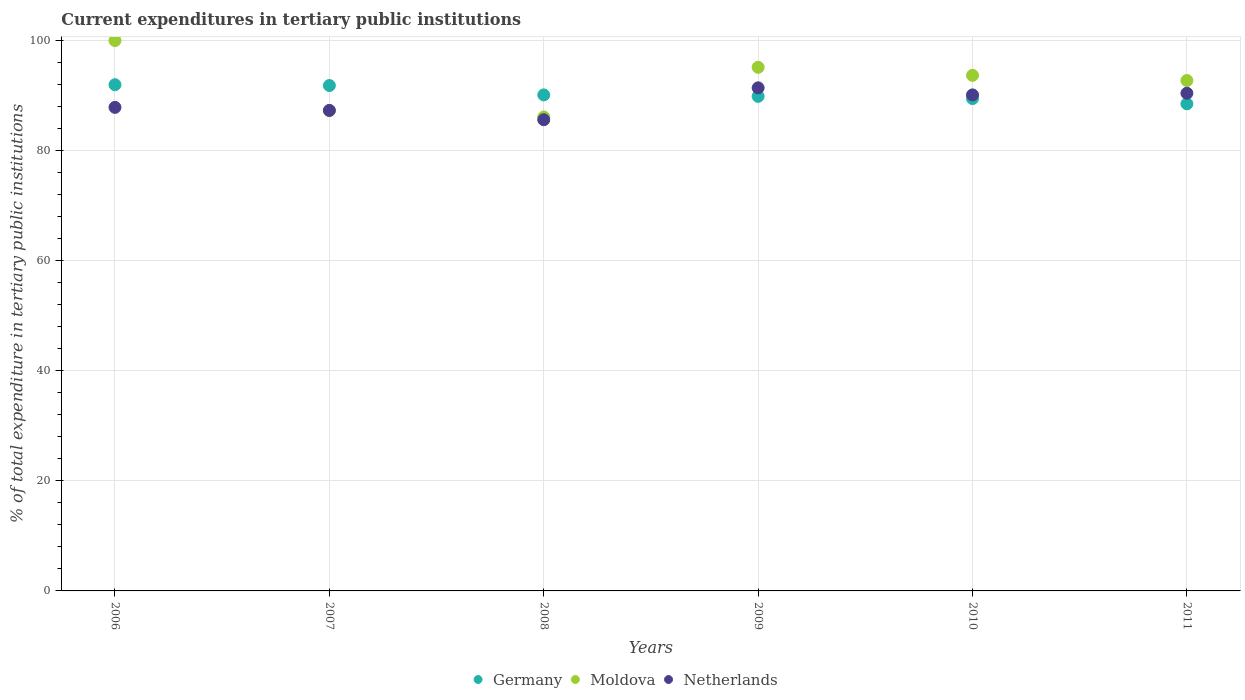How many different coloured dotlines are there?
Provide a short and direct response. 3. What is the current expenditures in tertiary public institutions in Netherlands in 2009?
Offer a terse response. 91.41. Across all years, what is the maximum current expenditures in tertiary public institutions in Netherlands?
Make the answer very short. 91.41. Across all years, what is the minimum current expenditures in tertiary public institutions in Netherlands?
Keep it short and to the point. 85.61. In which year was the current expenditures in tertiary public institutions in Netherlands maximum?
Keep it short and to the point. 2009. What is the total current expenditures in tertiary public institutions in Moldova in the graph?
Offer a very short reply. 554.92. What is the difference between the current expenditures in tertiary public institutions in Netherlands in 2007 and that in 2009?
Offer a very short reply. -4.1. What is the difference between the current expenditures in tertiary public institutions in Moldova in 2011 and the current expenditures in tertiary public institutions in Netherlands in 2009?
Your answer should be compact. 1.33. What is the average current expenditures in tertiary public institutions in Netherlands per year?
Provide a short and direct response. 88.79. In the year 2008, what is the difference between the current expenditures in tertiary public institutions in Moldova and current expenditures in tertiary public institutions in Germany?
Your answer should be very brief. -4.01. In how many years, is the current expenditures in tertiary public institutions in Moldova greater than 96 %?
Your response must be concise. 1. What is the ratio of the current expenditures in tertiary public institutions in Moldova in 2006 to that in 2007?
Offer a very short reply. 1.15. Is the current expenditures in tertiary public institutions in Netherlands in 2006 less than that in 2011?
Your response must be concise. Yes. What is the difference between the highest and the second highest current expenditures in tertiary public institutions in Germany?
Ensure brevity in your answer.  0.15. What is the difference between the highest and the lowest current expenditures in tertiary public institutions in Germany?
Offer a very short reply. 3.47. Does the current expenditures in tertiary public institutions in Germany monotonically increase over the years?
Offer a terse response. No. Is the current expenditures in tertiary public institutions in Moldova strictly greater than the current expenditures in tertiary public institutions in Germany over the years?
Make the answer very short. No. How many dotlines are there?
Give a very brief answer. 3. What is the difference between two consecutive major ticks on the Y-axis?
Offer a terse response. 20. Does the graph contain grids?
Keep it short and to the point. Yes. Where does the legend appear in the graph?
Provide a short and direct response. Bottom center. How many legend labels are there?
Your answer should be compact. 3. How are the legend labels stacked?
Ensure brevity in your answer.  Horizontal. What is the title of the graph?
Your answer should be compact. Current expenditures in tertiary public institutions. What is the label or title of the X-axis?
Offer a terse response. Years. What is the label or title of the Y-axis?
Give a very brief answer. % of total expenditure in tertiary public institutions. What is the % of total expenditure in tertiary public institutions in Germany in 2006?
Provide a succinct answer. 91.97. What is the % of total expenditure in tertiary public institutions in Moldova in 2006?
Make the answer very short. 100. What is the % of total expenditure in tertiary public institutions in Netherlands in 2006?
Your answer should be compact. 87.86. What is the % of total expenditure in tertiary public institutions of Germany in 2007?
Give a very brief answer. 91.83. What is the % of total expenditure in tertiary public institutions in Moldova in 2007?
Give a very brief answer. 87.26. What is the % of total expenditure in tertiary public institutions of Netherlands in 2007?
Give a very brief answer. 87.31. What is the % of total expenditure in tertiary public institutions of Germany in 2008?
Make the answer very short. 90.12. What is the % of total expenditure in tertiary public institutions of Moldova in 2008?
Keep it short and to the point. 86.11. What is the % of total expenditure in tertiary public institutions of Netherlands in 2008?
Provide a short and direct response. 85.61. What is the % of total expenditure in tertiary public institutions of Germany in 2009?
Offer a very short reply. 89.86. What is the % of total expenditure in tertiary public institutions of Moldova in 2009?
Your answer should be compact. 95.13. What is the % of total expenditure in tertiary public institutions in Netherlands in 2009?
Offer a very short reply. 91.41. What is the % of total expenditure in tertiary public institutions of Germany in 2010?
Your answer should be compact. 89.45. What is the % of total expenditure in tertiary public institutions of Moldova in 2010?
Offer a very short reply. 93.68. What is the % of total expenditure in tertiary public institutions of Netherlands in 2010?
Make the answer very short. 90.12. What is the % of total expenditure in tertiary public institutions of Germany in 2011?
Offer a very short reply. 88.5. What is the % of total expenditure in tertiary public institutions in Moldova in 2011?
Your answer should be very brief. 92.74. What is the % of total expenditure in tertiary public institutions in Netherlands in 2011?
Your answer should be very brief. 90.42. Across all years, what is the maximum % of total expenditure in tertiary public institutions in Germany?
Provide a succinct answer. 91.97. Across all years, what is the maximum % of total expenditure in tertiary public institutions of Moldova?
Keep it short and to the point. 100. Across all years, what is the maximum % of total expenditure in tertiary public institutions of Netherlands?
Offer a terse response. 91.41. Across all years, what is the minimum % of total expenditure in tertiary public institutions of Germany?
Provide a short and direct response. 88.5. Across all years, what is the minimum % of total expenditure in tertiary public institutions in Moldova?
Provide a short and direct response. 86.11. Across all years, what is the minimum % of total expenditure in tertiary public institutions in Netherlands?
Your answer should be compact. 85.61. What is the total % of total expenditure in tertiary public institutions in Germany in the graph?
Your answer should be very brief. 541.74. What is the total % of total expenditure in tertiary public institutions in Moldova in the graph?
Your answer should be compact. 554.92. What is the total % of total expenditure in tertiary public institutions in Netherlands in the graph?
Ensure brevity in your answer.  532.73. What is the difference between the % of total expenditure in tertiary public institutions in Germany in 2006 and that in 2007?
Offer a very short reply. 0.15. What is the difference between the % of total expenditure in tertiary public institutions of Moldova in 2006 and that in 2007?
Provide a short and direct response. 12.74. What is the difference between the % of total expenditure in tertiary public institutions of Netherlands in 2006 and that in 2007?
Your response must be concise. 0.55. What is the difference between the % of total expenditure in tertiary public institutions of Germany in 2006 and that in 2008?
Provide a succinct answer. 1.85. What is the difference between the % of total expenditure in tertiary public institutions in Moldova in 2006 and that in 2008?
Provide a succinct answer. 13.89. What is the difference between the % of total expenditure in tertiary public institutions in Netherlands in 2006 and that in 2008?
Give a very brief answer. 2.24. What is the difference between the % of total expenditure in tertiary public institutions of Germany in 2006 and that in 2009?
Ensure brevity in your answer.  2.11. What is the difference between the % of total expenditure in tertiary public institutions in Moldova in 2006 and that in 2009?
Give a very brief answer. 4.87. What is the difference between the % of total expenditure in tertiary public institutions in Netherlands in 2006 and that in 2009?
Keep it short and to the point. -3.55. What is the difference between the % of total expenditure in tertiary public institutions of Germany in 2006 and that in 2010?
Make the answer very short. 2.52. What is the difference between the % of total expenditure in tertiary public institutions of Moldova in 2006 and that in 2010?
Offer a terse response. 6.32. What is the difference between the % of total expenditure in tertiary public institutions of Netherlands in 2006 and that in 2010?
Ensure brevity in your answer.  -2.26. What is the difference between the % of total expenditure in tertiary public institutions of Germany in 2006 and that in 2011?
Keep it short and to the point. 3.47. What is the difference between the % of total expenditure in tertiary public institutions of Moldova in 2006 and that in 2011?
Ensure brevity in your answer.  7.26. What is the difference between the % of total expenditure in tertiary public institutions of Netherlands in 2006 and that in 2011?
Keep it short and to the point. -2.57. What is the difference between the % of total expenditure in tertiary public institutions in Germany in 2007 and that in 2008?
Offer a terse response. 1.7. What is the difference between the % of total expenditure in tertiary public institutions in Moldova in 2007 and that in 2008?
Offer a very short reply. 1.15. What is the difference between the % of total expenditure in tertiary public institutions of Netherlands in 2007 and that in 2008?
Offer a very short reply. 1.69. What is the difference between the % of total expenditure in tertiary public institutions in Germany in 2007 and that in 2009?
Give a very brief answer. 1.97. What is the difference between the % of total expenditure in tertiary public institutions of Moldova in 2007 and that in 2009?
Provide a short and direct response. -7.87. What is the difference between the % of total expenditure in tertiary public institutions in Netherlands in 2007 and that in 2009?
Give a very brief answer. -4.1. What is the difference between the % of total expenditure in tertiary public institutions of Germany in 2007 and that in 2010?
Keep it short and to the point. 2.37. What is the difference between the % of total expenditure in tertiary public institutions of Moldova in 2007 and that in 2010?
Offer a very short reply. -6.41. What is the difference between the % of total expenditure in tertiary public institutions of Netherlands in 2007 and that in 2010?
Your response must be concise. -2.81. What is the difference between the % of total expenditure in tertiary public institutions of Germany in 2007 and that in 2011?
Offer a terse response. 3.32. What is the difference between the % of total expenditure in tertiary public institutions in Moldova in 2007 and that in 2011?
Your answer should be compact. -5.47. What is the difference between the % of total expenditure in tertiary public institutions of Netherlands in 2007 and that in 2011?
Give a very brief answer. -3.12. What is the difference between the % of total expenditure in tertiary public institutions of Germany in 2008 and that in 2009?
Offer a terse response. 0.26. What is the difference between the % of total expenditure in tertiary public institutions of Moldova in 2008 and that in 2009?
Ensure brevity in your answer.  -9.03. What is the difference between the % of total expenditure in tertiary public institutions in Netherlands in 2008 and that in 2009?
Offer a terse response. -5.79. What is the difference between the % of total expenditure in tertiary public institutions in Germany in 2008 and that in 2010?
Give a very brief answer. 0.67. What is the difference between the % of total expenditure in tertiary public institutions in Moldova in 2008 and that in 2010?
Offer a very short reply. -7.57. What is the difference between the % of total expenditure in tertiary public institutions in Netherlands in 2008 and that in 2010?
Give a very brief answer. -4.51. What is the difference between the % of total expenditure in tertiary public institutions in Germany in 2008 and that in 2011?
Your response must be concise. 1.62. What is the difference between the % of total expenditure in tertiary public institutions in Moldova in 2008 and that in 2011?
Offer a very short reply. -6.63. What is the difference between the % of total expenditure in tertiary public institutions of Netherlands in 2008 and that in 2011?
Keep it short and to the point. -4.81. What is the difference between the % of total expenditure in tertiary public institutions of Germany in 2009 and that in 2010?
Ensure brevity in your answer.  0.41. What is the difference between the % of total expenditure in tertiary public institutions of Moldova in 2009 and that in 2010?
Make the answer very short. 1.46. What is the difference between the % of total expenditure in tertiary public institutions in Netherlands in 2009 and that in 2010?
Offer a very short reply. 1.28. What is the difference between the % of total expenditure in tertiary public institutions in Germany in 2009 and that in 2011?
Give a very brief answer. 1.36. What is the difference between the % of total expenditure in tertiary public institutions in Moldova in 2009 and that in 2011?
Your answer should be compact. 2.4. What is the difference between the % of total expenditure in tertiary public institutions in Netherlands in 2009 and that in 2011?
Give a very brief answer. 0.98. What is the difference between the % of total expenditure in tertiary public institutions of Germany in 2010 and that in 2011?
Make the answer very short. 0.95. What is the difference between the % of total expenditure in tertiary public institutions in Moldova in 2010 and that in 2011?
Provide a succinct answer. 0.94. What is the difference between the % of total expenditure in tertiary public institutions in Netherlands in 2010 and that in 2011?
Ensure brevity in your answer.  -0.3. What is the difference between the % of total expenditure in tertiary public institutions in Germany in 2006 and the % of total expenditure in tertiary public institutions in Moldova in 2007?
Keep it short and to the point. 4.71. What is the difference between the % of total expenditure in tertiary public institutions in Germany in 2006 and the % of total expenditure in tertiary public institutions in Netherlands in 2007?
Give a very brief answer. 4.67. What is the difference between the % of total expenditure in tertiary public institutions in Moldova in 2006 and the % of total expenditure in tertiary public institutions in Netherlands in 2007?
Provide a succinct answer. 12.69. What is the difference between the % of total expenditure in tertiary public institutions of Germany in 2006 and the % of total expenditure in tertiary public institutions of Moldova in 2008?
Give a very brief answer. 5.86. What is the difference between the % of total expenditure in tertiary public institutions of Germany in 2006 and the % of total expenditure in tertiary public institutions of Netherlands in 2008?
Your answer should be very brief. 6.36. What is the difference between the % of total expenditure in tertiary public institutions in Moldova in 2006 and the % of total expenditure in tertiary public institutions in Netherlands in 2008?
Your response must be concise. 14.39. What is the difference between the % of total expenditure in tertiary public institutions of Germany in 2006 and the % of total expenditure in tertiary public institutions of Moldova in 2009?
Make the answer very short. -3.16. What is the difference between the % of total expenditure in tertiary public institutions of Germany in 2006 and the % of total expenditure in tertiary public institutions of Netherlands in 2009?
Ensure brevity in your answer.  0.57. What is the difference between the % of total expenditure in tertiary public institutions of Moldova in 2006 and the % of total expenditure in tertiary public institutions of Netherlands in 2009?
Provide a succinct answer. 8.59. What is the difference between the % of total expenditure in tertiary public institutions in Germany in 2006 and the % of total expenditure in tertiary public institutions in Moldova in 2010?
Keep it short and to the point. -1.71. What is the difference between the % of total expenditure in tertiary public institutions in Germany in 2006 and the % of total expenditure in tertiary public institutions in Netherlands in 2010?
Your response must be concise. 1.85. What is the difference between the % of total expenditure in tertiary public institutions of Moldova in 2006 and the % of total expenditure in tertiary public institutions of Netherlands in 2010?
Give a very brief answer. 9.88. What is the difference between the % of total expenditure in tertiary public institutions in Germany in 2006 and the % of total expenditure in tertiary public institutions in Moldova in 2011?
Your answer should be very brief. -0.76. What is the difference between the % of total expenditure in tertiary public institutions of Germany in 2006 and the % of total expenditure in tertiary public institutions of Netherlands in 2011?
Your answer should be very brief. 1.55. What is the difference between the % of total expenditure in tertiary public institutions of Moldova in 2006 and the % of total expenditure in tertiary public institutions of Netherlands in 2011?
Offer a terse response. 9.58. What is the difference between the % of total expenditure in tertiary public institutions of Germany in 2007 and the % of total expenditure in tertiary public institutions of Moldova in 2008?
Your answer should be compact. 5.72. What is the difference between the % of total expenditure in tertiary public institutions of Germany in 2007 and the % of total expenditure in tertiary public institutions of Netherlands in 2008?
Your response must be concise. 6.21. What is the difference between the % of total expenditure in tertiary public institutions of Moldova in 2007 and the % of total expenditure in tertiary public institutions of Netherlands in 2008?
Offer a very short reply. 1.65. What is the difference between the % of total expenditure in tertiary public institutions of Germany in 2007 and the % of total expenditure in tertiary public institutions of Moldova in 2009?
Offer a terse response. -3.31. What is the difference between the % of total expenditure in tertiary public institutions in Germany in 2007 and the % of total expenditure in tertiary public institutions in Netherlands in 2009?
Keep it short and to the point. 0.42. What is the difference between the % of total expenditure in tertiary public institutions of Moldova in 2007 and the % of total expenditure in tertiary public institutions of Netherlands in 2009?
Ensure brevity in your answer.  -4.14. What is the difference between the % of total expenditure in tertiary public institutions of Germany in 2007 and the % of total expenditure in tertiary public institutions of Moldova in 2010?
Provide a succinct answer. -1.85. What is the difference between the % of total expenditure in tertiary public institutions in Germany in 2007 and the % of total expenditure in tertiary public institutions in Netherlands in 2010?
Offer a terse response. 1.7. What is the difference between the % of total expenditure in tertiary public institutions in Moldova in 2007 and the % of total expenditure in tertiary public institutions in Netherlands in 2010?
Keep it short and to the point. -2.86. What is the difference between the % of total expenditure in tertiary public institutions in Germany in 2007 and the % of total expenditure in tertiary public institutions in Moldova in 2011?
Offer a very short reply. -0.91. What is the difference between the % of total expenditure in tertiary public institutions in Germany in 2007 and the % of total expenditure in tertiary public institutions in Netherlands in 2011?
Keep it short and to the point. 1.4. What is the difference between the % of total expenditure in tertiary public institutions of Moldova in 2007 and the % of total expenditure in tertiary public institutions of Netherlands in 2011?
Make the answer very short. -3.16. What is the difference between the % of total expenditure in tertiary public institutions of Germany in 2008 and the % of total expenditure in tertiary public institutions of Moldova in 2009?
Your answer should be very brief. -5.01. What is the difference between the % of total expenditure in tertiary public institutions of Germany in 2008 and the % of total expenditure in tertiary public institutions of Netherlands in 2009?
Offer a terse response. -1.28. What is the difference between the % of total expenditure in tertiary public institutions of Moldova in 2008 and the % of total expenditure in tertiary public institutions of Netherlands in 2009?
Make the answer very short. -5.3. What is the difference between the % of total expenditure in tertiary public institutions in Germany in 2008 and the % of total expenditure in tertiary public institutions in Moldova in 2010?
Provide a short and direct response. -3.56. What is the difference between the % of total expenditure in tertiary public institutions in Germany in 2008 and the % of total expenditure in tertiary public institutions in Netherlands in 2010?
Your answer should be compact. 0. What is the difference between the % of total expenditure in tertiary public institutions in Moldova in 2008 and the % of total expenditure in tertiary public institutions in Netherlands in 2010?
Your answer should be compact. -4.01. What is the difference between the % of total expenditure in tertiary public institutions of Germany in 2008 and the % of total expenditure in tertiary public institutions of Moldova in 2011?
Make the answer very short. -2.61. What is the difference between the % of total expenditure in tertiary public institutions in Germany in 2008 and the % of total expenditure in tertiary public institutions in Netherlands in 2011?
Give a very brief answer. -0.3. What is the difference between the % of total expenditure in tertiary public institutions of Moldova in 2008 and the % of total expenditure in tertiary public institutions of Netherlands in 2011?
Offer a terse response. -4.31. What is the difference between the % of total expenditure in tertiary public institutions of Germany in 2009 and the % of total expenditure in tertiary public institutions of Moldova in 2010?
Your answer should be compact. -3.82. What is the difference between the % of total expenditure in tertiary public institutions of Germany in 2009 and the % of total expenditure in tertiary public institutions of Netherlands in 2010?
Keep it short and to the point. -0.26. What is the difference between the % of total expenditure in tertiary public institutions in Moldova in 2009 and the % of total expenditure in tertiary public institutions in Netherlands in 2010?
Ensure brevity in your answer.  5.01. What is the difference between the % of total expenditure in tertiary public institutions of Germany in 2009 and the % of total expenditure in tertiary public institutions of Moldova in 2011?
Give a very brief answer. -2.88. What is the difference between the % of total expenditure in tertiary public institutions of Germany in 2009 and the % of total expenditure in tertiary public institutions of Netherlands in 2011?
Provide a succinct answer. -0.56. What is the difference between the % of total expenditure in tertiary public institutions in Moldova in 2009 and the % of total expenditure in tertiary public institutions in Netherlands in 2011?
Provide a succinct answer. 4.71. What is the difference between the % of total expenditure in tertiary public institutions in Germany in 2010 and the % of total expenditure in tertiary public institutions in Moldova in 2011?
Your response must be concise. -3.28. What is the difference between the % of total expenditure in tertiary public institutions in Germany in 2010 and the % of total expenditure in tertiary public institutions in Netherlands in 2011?
Offer a terse response. -0.97. What is the difference between the % of total expenditure in tertiary public institutions of Moldova in 2010 and the % of total expenditure in tertiary public institutions of Netherlands in 2011?
Offer a terse response. 3.26. What is the average % of total expenditure in tertiary public institutions in Germany per year?
Offer a terse response. 90.29. What is the average % of total expenditure in tertiary public institutions of Moldova per year?
Make the answer very short. 92.49. What is the average % of total expenditure in tertiary public institutions in Netherlands per year?
Offer a terse response. 88.79. In the year 2006, what is the difference between the % of total expenditure in tertiary public institutions in Germany and % of total expenditure in tertiary public institutions in Moldova?
Provide a succinct answer. -8.03. In the year 2006, what is the difference between the % of total expenditure in tertiary public institutions of Germany and % of total expenditure in tertiary public institutions of Netherlands?
Your response must be concise. 4.12. In the year 2006, what is the difference between the % of total expenditure in tertiary public institutions of Moldova and % of total expenditure in tertiary public institutions of Netherlands?
Keep it short and to the point. 12.14. In the year 2007, what is the difference between the % of total expenditure in tertiary public institutions of Germany and % of total expenditure in tertiary public institutions of Moldova?
Make the answer very short. 4.56. In the year 2007, what is the difference between the % of total expenditure in tertiary public institutions of Germany and % of total expenditure in tertiary public institutions of Netherlands?
Make the answer very short. 4.52. In the year 2007, what is the difference between the % of total expenditure in tertiary public institutions of Moldova and % of total expenditure in tertiary public institutions of Netherlands?
Your answer should be very brief. -0.04. In the year 2008, what is the difference between the % of total expenditure in tertiary public institutions in Germany and % of total expenditure in tertiary public institutions in Moldova?
Ensure brevity in your answer.  4.01. In the year 2008, what is the difference between the % of total expenditure in tertiary public institutions of Germany and % of total expenditure in tertiary public institutions of Netherlands?
Your answer should be very brief. 4.51. In the year 2008, what is the difference between the % of total expenditure in tertiary public institutions in Moldova and % of total expenditure in tertiary public institutions in Netherlands?
Your answer should be very brief. 0.5. In the year 2009, what is the difference between the % of total expenditure in tertiary public institutions of Germany and % of total expenditure in tertiary public institutions of Moldova?
Your answer should be very brief. -5.28. In the year 2009, what is the difference between the % of total expenditure in tertiary public institutions of Germany and % of total expenditure in tertiary public institutions of Netherlands?
Your response must be concise. -1.55. In the year 2009, what is the difference between the % of total expenditure in tertiary public institutions in Moldova and % of total expenditure in tertiary public institutions in Netherlands?
Make the answer very short. 3.73. In the year 2010, what is the difference between the % of total expenditure in tertiary public institutions in Germany and % of total expenditure in tertiary public institutions in Moldova?
Keep it short and to the point. -4.23. In the year 2010, what is the difference between the % of total expenditure in tertiary public institutions in Germany and % of total expenditure in tertiary public institutions in Netherlands?
Ensure brevity in your answer.  -0.67. In the year 2010, what is the difference between the % of total expenditure in tertiary public institutions in Moldova and % of total expenditure in tertiary public institutions in Netherlands?
Give a very brief answer. 3.56. In the year 2011, what is the difference between the % of total expenditure in tertiary public institutions in Germany and % of total expenditure in tertiary public institutions in Moldova?
Offer a very short reply. -4.23. In the year 2011, what is the difference between the % of total expenditure in tertiary public institutions in Germany and % of total expenditure in tertiary public institutions in Netherlands?
Offer a very short reply. -1.92. In the year 2011, what is the difference between the % of total expenditure in tertiary public institutions in Moldova and % of total expenditure in tertiary public institutions in Netherlands?
Provide a succinct answer. 2.31. What is the ratio of the % of total expenditure in tertiary public institutions in Germany in 2006 to that in 2007?
Your response must be concise. 1. What is the ratio of the % of total expenditure in tertiary public institutions of Moldova in 2006 to that in 2007?
Ensure brevity in your answer.  1.15. What is the ratio of the % of total expenditure in tertiary public institutions of Germany in 2006 to that in 2008?
Offer a terse response. 1.02. What is the ratio of the % of total expenditure in tertiary public institutions in Moldova in 2006 to that in 2008?
Your answer should be compact. 1.16. What is the ratio of the % of total expenditure in tertiary public institutions of Netherlands in 2006 to that in 2008?
Provide a short and direct response. 1.03. What is the ratio of the % of total expenditure in tertiary public institutions in Germany in 2006 to that in 2009?
Make the answer very short. 1.02. What is the ratio of the % of total expenditure in tertiary public institutions of Moldova in 2006 to that in 2009?
Your answer should be very brief. 1.05. What is the ratio of the % of total expenditure in tertiary public institutions of Netherlands in 2006 to that in 2009?
Provide a short and direct response. 0.96. What is the ratio of the % of total expenditure in tertiary public institutions of Germany in 2006 to that in 2010?
Provide a short and direct response. 1.03. What is the ratio of the % of total expenditure in tertiary public institutions of Moldova in 2006 to that in 2010?
Offer a very short reply. 1.07. What is the ratio of the % of total expenditure in tertiary public institutions in Netherlands in 2006 to that in 2010?
Provide a short and direct response. 0.97. What is the ratio of the % of total expenditure in tertiary public institutions in Germany in 2006 to that in 2011?
Make the answer very short. 1.04. What is the ratio of the % of total expenditure in tertiary public institutions in Moldova in 2006 to that in 2011?
Make the answer very short. 1.08. What is the ratio of the % of total expenditure in tertiary public institutions of Netherlands in 2006 to that in 2011?
Your answer should be compact. 0.97. What is the ratio of the % of total expenditure in tertiary public institutions in Germany in 2007 to that in 2008?
Keep it short and to the point. 1.02. What is the ratio of the % of total expenditure in tertiary public institutions of Moldova in 2007 to that in 2008?
Ensure brevity in your answer.  1.01. What is the ratio of the % of total expenditure in tertiary public institutions of Netherlands in 2007 to that in 2008?
Make the answer very short. 1.02. What is the ratio of the % of total expenditure in tertiary public institutions in Germany in 2007 to that in 2009?
Provide a succinct answer. 1.02. What is the ratio of the % of total expenditure in tertiary public institutions of Moldova in 2007 to that in 2009?
Provide a short and direct response. 0.92. What is the ratio of the % of total expenditure in tertiary public institutions in Netherlands in 2007 to that in 2009?
Your response must be concise. 0.96. What is the ratio of the % of total expenditure in tertiary public institutions of Germany in 2007 to that in 2010?
Give a very brief answer. 1.03. What is the ratio of the % of total expenditure in tertiary public institutions in Moldova in 2007 to that in 2010?
Give a very brief answer. 0.93. What is the ratio of the % of total expenditure in tertiary public institutions of Netherlands in 2007 to that in 2010?
Provide a short and direct response. 0.97. What is the ratio of the % of total expenditure in tertiary public institutions in Germany in 2007 to that in 2011?
Provide a succinct answer. 1.04. What is the ratio of the % of total expenditure in tertiary public institutions of Moldova in 2007 to that in 2011?
Your answer should be compact. 0.94. What is the ratio of the % of total expenditure in tertiary public institutions in Netherlands in 2007 to that in 2011?
Keep it short and to the point. 0.97. What is the ratio of the % of total expenditure in tertiary public institutions in Germany in 2008 to that in 2009?
Your answer should be very brief. 1. What is the ratio of the % of total expenditure in tertiary public institutions in Moldova in 2008 to that in 2009?
Give a very brief answer. 0.91. What is the ratio of the % of total expenditure in tertiary public institutions of Netherlands in 2008 to that in 2009?
Ensure brevity in your answer.  0.94. What is the ratio of the % of total expenditure in tertiary public institutions in Germany in 2008 to that in 2010?
Offer a terse response. 1.01. What is the ratio of the % of total expenditure in tertiary public institutions of Moldova in 2008 to that in 2010?
Give a very brief answer. 0.92. What is the ratio of the % of total expenditure in tertiary public institutions in Netherlands in 2008 to that in 2010?
Ensure brevity in your answer.  0.95. What is the ratio of the % of total expenditure in tertiary public institutions in Germany in 2008 to that in 2011?
Provide a succinct answer. 1.02. What is the ratio of the % of total expenditure in tertiary public institutions in Moldova in 2008 to that in 2011?
Keep it short and to the point. 0.93. What is the ratio of the % of total expenditure in tertiary public institutions of Netherlands in 2008 to that in 2011?
Your answer should be compact. 0.95. What is the ratio of the % of total expenditure in tertiary public institutions of Germany in 2009 to that in 2010?
Ensure brevity in your answer.  1. What is the ratio of the % of total expenditure in tertiary public institutions in Moldova in 2009 to that in 2010?
Provide a short and direct response. 1.02. What is the ratio of the % of total expenditure in tertiary public institutions of Netherlands in 2009 to that in 2010?
Offer a terse response. 1.01. What is the ratio of the % of total expenditure in tertiary public institutions in Germany in 2009 to that in 2011?
Ensure brevity in your answer.  1.02. What is the ratio of the % of total expenditure in tertiary public institutions in Moldova in 2009 to that in 2011?
Provide a short and direct response. 1.03. What is the ratio of the % of total expenditure in tertiary public institutions of Netherlands in 2009 to that in 2011?
Make the answer very short. 1.01. What is the ratio of the % of total expenditure in tertiary public institutions of Germany in 2010 to that in 2011?
Make the answer very short. 1.01. What is the ratio of the % of total expenditure in tertiary public institutions in Moldova in 2010 to that in 2011?
Make the answer very short. 1.01. What is the difference between the highest and the second highest % of total expenditure in tertiary public institutions in Germany?
Your response must be concise. 0.15. What is the difference between the highest and the second highest % of total expenditure in tertiary public institutions of Moldova?
Provide a short and direct response. 4.87. What is the difference between the highest and the second highest % of total expenditure in tertiary public institutions in Netherlands?
Keep it short and to the point. 0.98. What is the difference between the highest and the lowest % of total expenditure in tertiary public institutions of Germany?
Keep it short and to the point. 3.47. What is the difference between the highest and the lowest % of total expenditure in tertiary public institutions of Moldova?
Your response must be concise. 13.89. What is the difference between the highest and the lowest % of total expenditure in tertiary public institutions of Netherlands?
Offer a terse response. 5.79. 